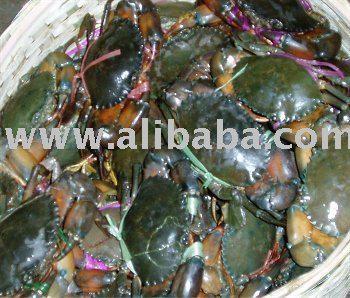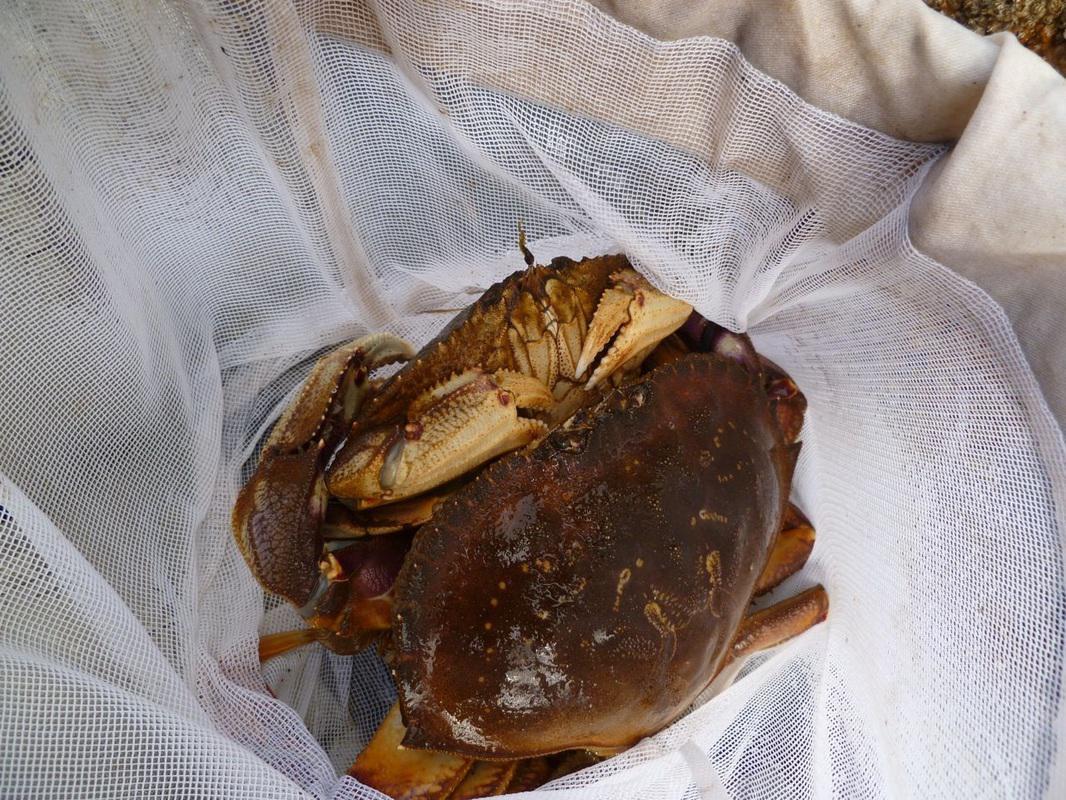The first image is the image on the left, the second image is the image on the right. Given the left and right images, does the statement "In at least one image there is a single purple headed crab crawling in the ground." hold true? Answer yes or no. No. The first image is the image on the left, the second image is the image on the right. Evaluate the accuracy of this statement regarding the images: "One image shows one forward-facing crab with a bright purple shell, and no image contains more than two crabs.". Is it true? Answer yes or no. No. 